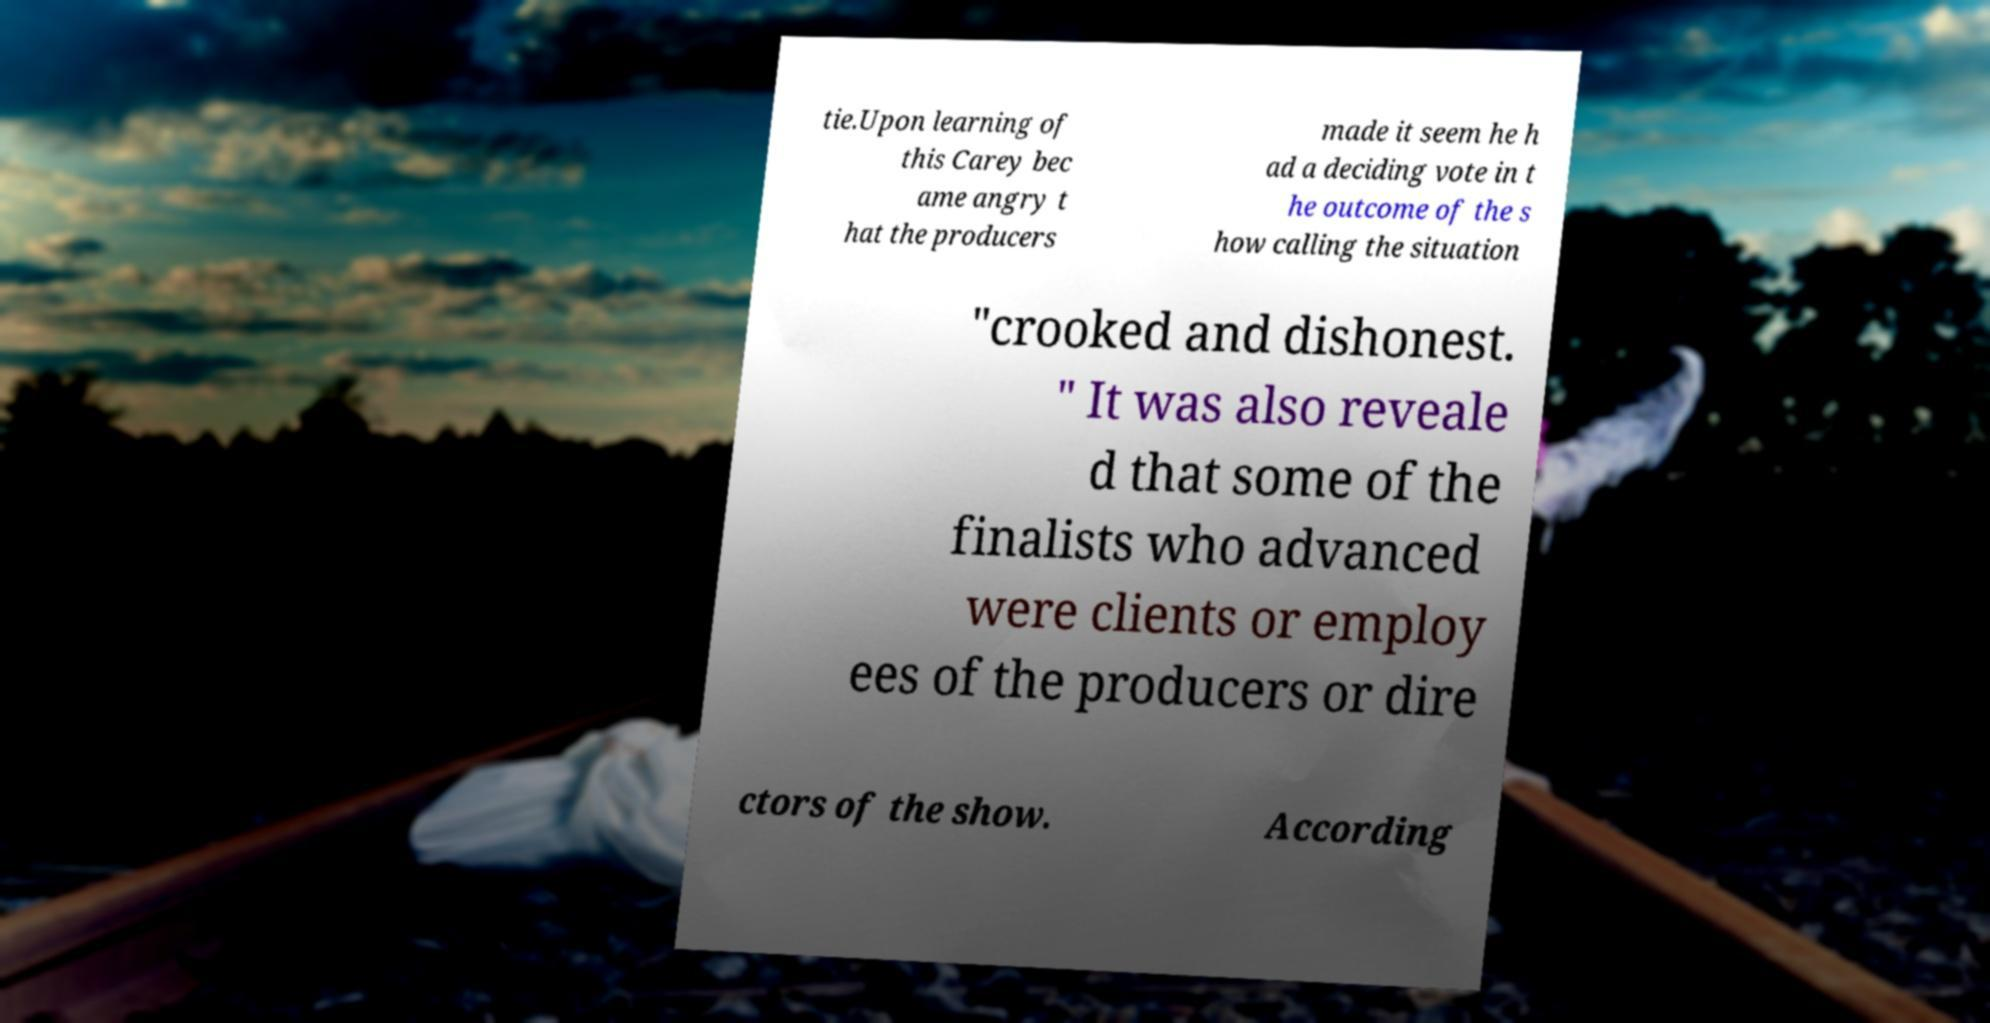There's text embedded in this image that I need extracted. Can you transcribe it verbatim? tie.Upon learning of this Carey bec ame angry t hat the producers made it seem he h ad a deciding vote in t he outcome of the s how calling the situation "crooked and dishonest. " It was also reveale d that some of the finalists who advanced were clients or employ ees of the producers or dire ctors of the show. According 